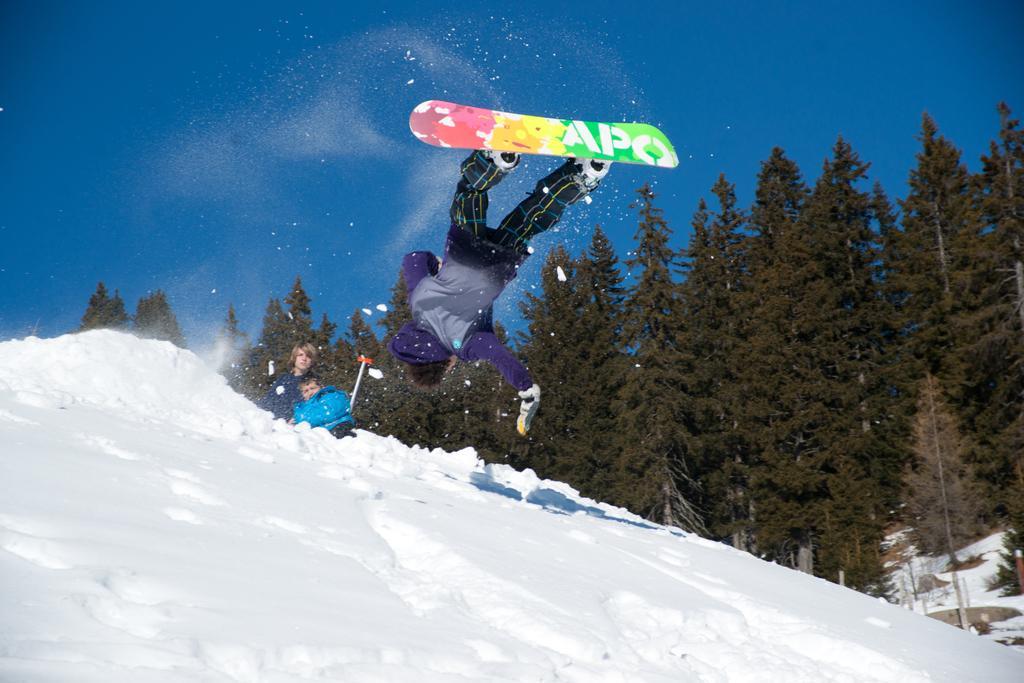In one or two sentences, can you explain what this image depicts? There is a man on the skateboard in the air in the foreground, there is snow at the bottom side. There are people, trees and the sky in the background area. 